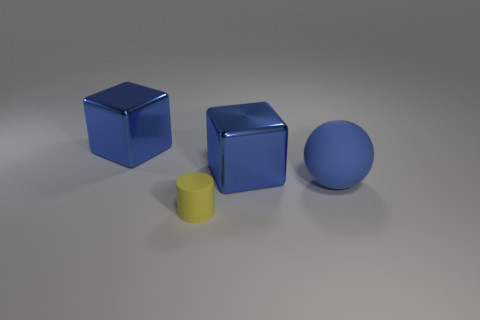The metallic thing to the left of the tiny thing has what shape?
Your answer should be very brief. Cube. How many tiny yellow cylinders are there?
Your answer should be very brief. 1. Does the blue ball have the same material as the yellow thing?
Ensure brevity in your answer.  Yes. Is the number of cylinders that are left of the blue matte object greater than the number of big blue cubes?
Your response must be concise. No. What number of objects are tiny yellow things or matte objects that are to the left of the blue rubber sphere?
Ensure brevity in your answer.  1. Are there more tiny yellow things that are behind the blue rubber object than rubber things that are in front of the tiny thing?
Give a very brief answer. No. There is a large block behind the big metal cube right of the large blue metal object that is to the left of the small thing; what is it made of?
Ensure brevity in your answer.  Metal. There is a blue thing that is made of the same material as the small yellow cylinder; what shape is it?
Ensure brevity in your answer.  Sphere. Is there a yellow object on the right side of the large blue shiny block that is on the right side of the tiny matte object?
Offer a very short reply. No. What is the size of the blue rubber thing?
Provide a short and direct response. Large. 